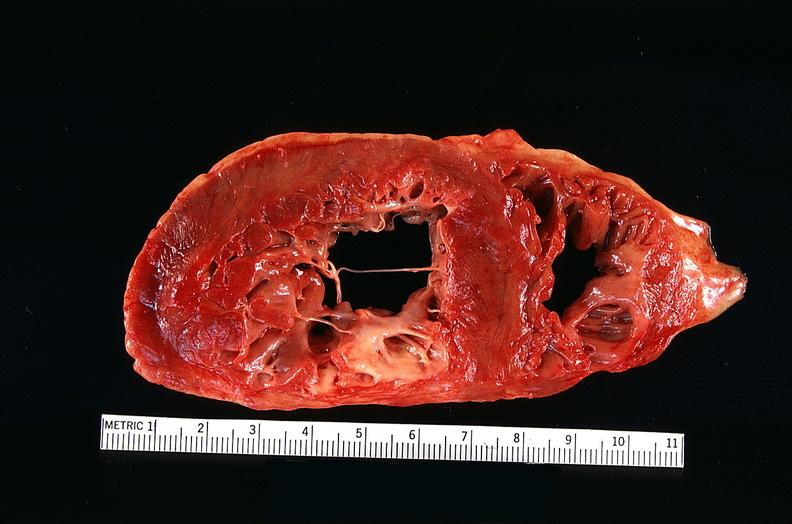how many vessel does this image show congestive heart failure, coronary artery disease?
Answer the question using a single word or phrase. Three 